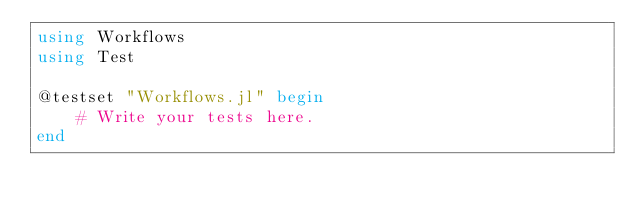Convert code to text. <code><loc_0><loc_0><loc_500><loc_500><_Julia_>using Workflows
using Test

@testset "Workflows.jl" begin
    # Write your tests here.
end
</code> 